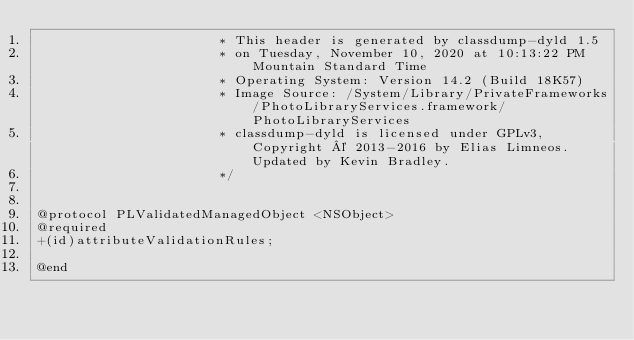Convert code to text. <code><loc_0><loc_0><loc_500><loc_500><_C_>                       * This header is generated by classdump-dyld 1.5
                       * on Tuesday, November 10, 2020 at 10:13:22 PM Mountain Standard Time
                       * Operating System: Version 14.2 (Build 18K57)
                       * Image Source: /System/Library/PrivateFrameworks/PhotoLibraryServices.framework/PhotoLibraryServices
                       * classdump-dyld is licensed under GPLv3, Copyright © 2013-2016 by Elias Limneos. Updated by Kevin Bradley.
                       */


@protocol PLValidatedManagedObject <NSObject>
@required
+(id)attributeValidationRules;

@end

</code> 